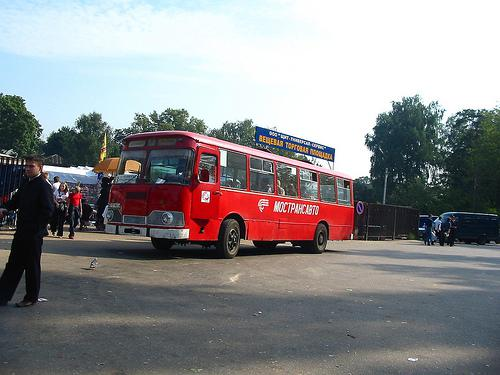Question: where was the picture taken?
Choices:
A. Morning.
B. Noon.
C. No indication of where.
D. Night.
Answer with the letter. Answer: C Question: how many buses are parked?
Choices:
A. Two.
B. Three.
C. One.
D. Eight.
Answer with the letter. Answer: C Question: when did the bus arrive?
Choices:
A. Morning.
B. Noon.
C. Evening.
D. No indication of when.
Answer with the letter. Answer: D Question: what color is the bus?
Choices:
A. Red.
B. Yellow.
C. White.
D. Blue.
Answer with the letter. Answer: A Question: what is written on the bus?
Choices:
A. Joe's.
B. Not identifiable.
C. Fred's.
D. Polo.
Answer with the letter. Answer: B 